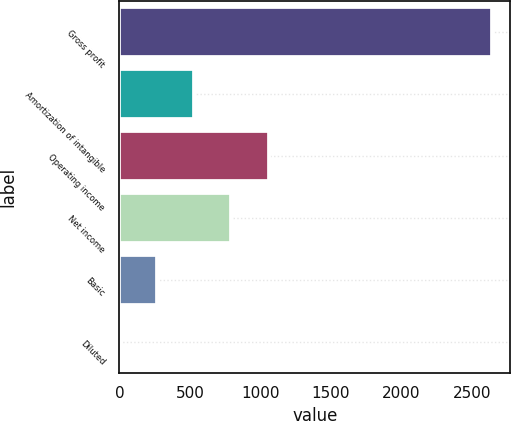<chart> <loc_0><loc_0><loc_500><loc_500><bar_chart><fcel>Gross profit<fcel>Amortization of intangible<fcel>Operating income<fcel>Net income<fcel>Basic<fcel>Diluted<nl><fcel>2638.1<fcel>530.81<fcel>1057.63<fcel>794.22<fcel>267.4<fcel>3.99<nl></chart> 